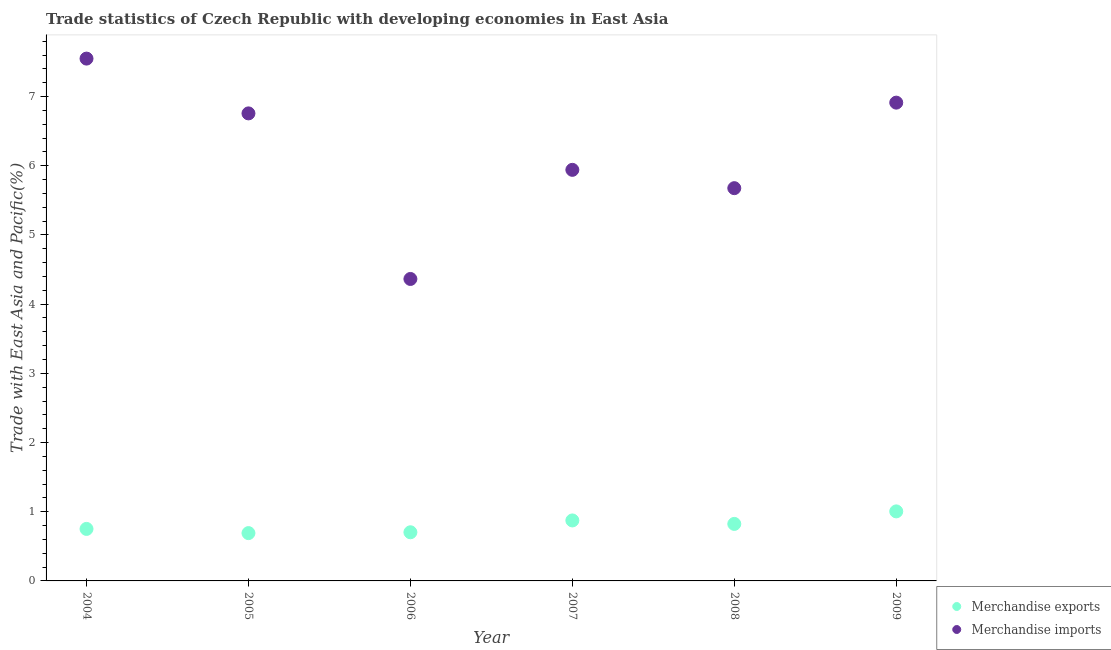How many different coloured dotlines are there?
Keep it short and to the point. 2. What is the merchandise exports in 2005?
Provide a succinct answer. 0.69. Across all years, what is the maximum merchandise imports?
Provide a succinct answer. 7.55. Across all years, what is the minimum merchandise exports?
Keep it short and to the point. 0.69. In which year was the merchandise imports minimum?
Give a very brief answer. 2006. What is the total merchandise imports in the graph?
Ensure brevity in your answer.  37.2. What is the difference between the merchandise imports in 2004 and that in 2006?
Ensure brevity in your answer.  3.18. What is the difference between the merchandise imports in 2009 and the merchandise exports in 2004?
Provide a succinct answer. 6.16. What is the average merchandise imports per year?
Offer a very short reply. 6.2. In the year 2007, what is the difference between the merchandise exports and merchandise imports?
Offer a very short reply. -5.07. What is the ratio of the merchandise exports in 2006 to that in 2007?
Your answer should be very brief. 0.8. Is the merchandise exports in 2004 less than that in 2005?
Offer a terse response. No. What is the difference between the highest and the second highest merchandise imports?
Offer a terse response. 0.64. What is the difference between the highest and the lowest merchandise imports?
Offer a very short reply. 3.18. Is the merchandise exports strictly less than the merchandise imports over the years?
Offer a terse response. Yes. How many dotlines are there?
Make the answer very short. 2. How many years are there in the graph?
Your answer should be very brief. 6. What is the difference between two consecutive major ticks on the Y-axis?
Your answer should be very brief. 1. Does the graph contain any zero values?
Make the answer very short. No. Where does the legend appear in the graph?
Offer a terse response. Bottom right. How are the legend labels stacked?
Provide a succinct answer. Vertical. What is the title of the graph?
Make the answer very short. Trade statistics of Czech Republic with developing economies in East Asia. Does "IMF nonconcessional" appear as one of the legend labels in the graph?
Offer a terse response. No. What is the label or title of the Y-axis?
Ensure brevity in your answer.  Trade with East Asia and Pacific(%). What is the Trade with East Asia and Pacific(%) of Merchandise exports in 2004?
Your answer should be very brief. 0.75. What is the Trade with East Asia and Pacific(%) in Merchandise imports in 2004?
Ensure brevity in your answer.  7.55. What is the Trade with East Asia and Pacific(%) of Merchandise exports in 2005?
Your answer should be very brief. 0.69. What is the Trade with East Asia and Pacific(%) in Merchandise imports in 2005?
Offer a very short reply. 6.76. What is the Trade with East Asia and Pacific(%) in Merchandise exports in 2006?
Provide a short and direct response. 0.7. What is the Trade with East Asia and Pacific(%) in Merchandise imports in 2006?
Keep it short and to the point. 4.36. What is the Trade with East Asia and Pacific(%) in Merchandise exports in 2007?
Provide a succinct answer. 0.87. What is the Trade with East Asia and Pacific(%) in Merchandise imports in 2007?
Make the answer very short. 5.94. What is the Trade with East Asia and Pacific(%) in Merchandise exports in 2008?
Keep it short and to the point. 0.82. What is the Trade with East Asia and Pacific(%) of Merchandise imports in 2008?
Offer a terse response. 5.68. What is the Trade with East Asia and Pacific(%) of Merchandise exports in 2009?
Provide a succinct answer. 1. What is the Trade with East Asia and Pacific(%) in Merchandise imports in 2009?
Ensure brevity in your answer.  6.91. Across all years, what is the maximum Trade with East Asia and Pacific(%) of Merchandise exports?
Provide a succinct answer. 1. Across all years, what is the maximum Trade with East Asia and Pacific(%) of Merchandise imports?
Provide a short and direct response. 7.55. Across all years, what is the minimum Trade with East Asia and Pacific(%) in Merchandise exports?
Provide a succinct answer. 0.69. Across all years, what is the minimum Trade with East Asia and Pacific(%) of Merchandise imports?
Your answer should be compact. 4.36. What is the total Trade with East Asia and Pacific(%) in Merchandise exports in the graph?
Offer a very short reply. 4.85. What is the total Trade with East Asia and Pacific(%) in Merchandise imports in the graph?
Your answer should be very brief. 37.2. What is the difference between the Trade with East Asia and Pacific(%) in Merchandise exports in 2004 and that in 2005?
Offer a very short reply. 0.06. What is the difference between the Trade with East Asia and Pacific(%) in Merchandise imports in 2004 and that in 2005?
Ensure brevity in your answer.  0.79. What is the difference between the Trade with East Asia and Pacific(%) of Merchandise exports in 2004 and that in 2006?
Offer a terse response. 0.05. What is the difference between the Trade with East Asia and Pacific(%) in Merchandise imports in 2004 and that in 2006?
Give a very brief answer. 3.18. What is the difference between the Trade with East Asia and Pacific(%) in Merchandise exports in 2004 and that in 2007?
Make the answer very short. -0.12. What is the difference between the Trade with East Asia and Pacific(%) in Merchandise imports in 2004 and that in 2007?
Your response must be concise. 1.61. What is the difference between the Trade with East Asia and Pacific(%) of Merchandise exports in 2004 and that in 2008?
Offer a very short reply. -0.07. What is the difference between the Trade with East Asia and Pacific(%) in Merchandise imports in 2004 and that in 2008?
Your response must be concise. 1.87. What is the difference between the Trade with East Asia and Pacific(%) of Merchandise exports in 2004 and that in 2009?
Offer a very short reply. -0.25. What is the difference between the Trade with East Asia and Pacific(%) in Merchandise imports in 2004 and that in 2009?
Ensure brevity in your answer.  0.64. What is the difference between the Trade with East Asia and Pacific(%) of Merchandise exports in 2005 and that in 2006?
Your response must be concise. -0.01. What is the difference between the Trade with East Asia and Pacific(%) of Merchandise imports in 2005 and that in 2006?
Your answer should be very brief. 2.39. What is the difference between the Trade with East Asia and Pacific(%) in Merchandise exports in 2005 and that in 2007?
Your answer should be very brief. -0.18. What is the difference between the Trade with East Asia and Pacific(%) of Merchandise imports in 2005 and that in 2007?
Provide a succinct answer. 0.82. What is the difference between the Trade with East Asia and Pacific(%) of Merchandise exports in 2005 and that in 2008?
Make the answer very short. -0.13. What is the difference between the Trade with East Asia and Pacific(%) of Merchandise imports in 2005 and that in 2008?
Your answer should be very brief. 1.08. What is the difference between the Trade with East Asia and Pacific(%) of Merchandise exports in 2005 and that in 2009?
Your answer should be compact. -0.31. What is the difference between the Trade with East Asia and Pacific(%) in Merchandise imports in 2005 and that in 2009?
Ensure brevity in your answer.  -0.16. What is the difference between the Trade with East Asia and Pacific(%) in Merchandise exports in 2006 and that in 2007?
Give a very brief answer. -0.17. What is the difference between the Trade with East Asia and Pacific(%) of Merchandise imports in 2006 and that in 2007?
Make the answer very short. -1.58. What is the difference between the Trade with East Asia and Pacific(%) in Merchandise exports in 2006 and that in 2008?
Keep it short and to the point. -0.12. What is the difference between the Trade with East Asia and Pacific(%) in Merchandise imports in 2006 and that in 2008?
Offer a terse response. -1.31. What is the difference between the Trade with East Asia and Pacific(%) of Merchandise exports in 2006 and that in 2009?
Offer a terse response. -0.3. What is the difference between the Trade with East Asia and Pacific(%) in Merchandise imports in 2006 and that in 2009?
Make the answer very short. -2.55. What is the difference between the Trade with East Asia and Pacific(%) in Merchandise exports in 2007 and that in 2008?
Offer a terse response. 0.05. What is the difference between the Trade with East Asia and Pacific(%) in Merchandise imports in 2007 and that in 2008?
Keep it short and to the point. 0.26. What is the difference between the Trade with East Asia and Pacific(%) of Merchandise exports in 2007 and that in 2009?
Ensure brevity in your answer.  -0.13. What is the difference between the Trade with East Asia and Pacific(%) in Merchandise imports in 2007 and that in 2009?
Your answer should be very brief. -0.97. What is the difference between the Trade with East Asia and Pacific(%) of Merchandise exports in 2008 and that in 2009?
Provide a succinct answer. -0.18. What is the difference between the Trade with East Asia and Pacific(%) in Merchandise imports in 2008 and that in 2009?
Make the answer very short. -1.24. What is the difference between the Trade with East Asia and Pacific(%) of Merchandise exports in 2004 and the Trade with East Asia and Pacific(%) of Merchandise imports in 2005?
Give a very brief answer. -6.01. What is the difference between the Trade with East Asia and Pacific(%) in Merchandise exports in 2004 and the Trade with East Asia and Pacific(%) in Merchandise imports in 2006?
Give a very brief answer. -3.61. What is the difference between the Trade with East Asia and Pacific(%) in Merchandise exports in 2004 and the Trade with East Asia and Pacific(%) in Merchandise imports in 2007?
Provide a short and direct response. -5.19. What is the difference between the Trade with East Asia and Pacific(%) of Merchandise exports in 2004 and the Trade with East Asia and Pacific(%) of Merchandise imports in 2008?
Your answer should be very brief. -4.92. What is the difference between the Trade with East Asia and Pacific(%) of Merchandise exports in 2004 and the Trade with East Asia and Pacific(%) of Merchandise imports in 2009?
Give a very brief answer. -6.16. What is the difference between the Trade with East Asia and Pacific(%) in Merchandise exports in 2005 and the Trade with East Asia and Pacific(%) in Merchandise imports in 2006?
Your answer should be very brief. -3.67. What is the difference between the Trade with East Asia and Pacific(%) of Merchandise exports in 2005 and the Trade with East Asia and Pacific(%) of Merchandise imports in 2007?
Give a very brief answer. -5.25. What is the difference between the Trade with East Asia and Pacific(%) of Merchandise exports in 2005 and the Trade with East Asia and Pacific(%) of Merchandise imports in 2008?
Keep it short and to the point. -4.99. What is the difference between the Trade with East Asia and Pacific(%) in Merchandise exports in 2005 and the Trade with East Asia and Pacific(%) in Merchandise imports in 2009?
Offer a terse response. -6.22. What is the difference between the Trade with East Asia and Pacific(%) of Merchandise exports in 2006 and the Trade with East Asia and Pacific(%) of Merchandise imports in 2007?
Your answer should be very brief. -5.24. What is the difference between the Trade with East Asia and Pacific(%) of Merchandise exports in 2006 and the Trade with East Asia and Pacific(%) of Merchandise imports in 2008?
Give a very brief answer. -4.97. What is the difference between the Trade with East Asia and Pacific(%) of Merchandise exports in 2006 and the Trade with East Asia and Pacific(%) of Merchandise imports in 2009?
Your answer should be compact. -6.21. What is the difference between the Trade with East Asia and Pacific(%) in Merchandise exports in 2007 and the Trade with East Asia and Pacific(%) in Merchandise imports in 2008?
Give a very brief answer. -4.8. What is the difference between the Trade with East Asia and Pacific(%) in Merchandise exports in 2007 and the Trade with East Asia and Pacific(%) in Merchandise imports in 2009?
Provide a succinct answer. -6.04. What is the difference between the Trade with East Asia and Pacific(%) of Merchandise exports in 2008 and the Trade with East Asia and Pacific(%) of Merchandise imports in 2009?
Your answer should be compact. -6.09. What is the average Trade with East Asia and Pacific(%) of Merchandise exports per year?
Keep it short and to the point. 0.81. In the year 2004, what is the difference between the Trade with East Asia and Pacific(%) of Merchandise exports and Trade with East Asia and Pacific(%) of Merchandise imports?
Make the answer very short. -6.8. In the year 2005, what is the difference between the Trade with East Asia and Pacific(%) of Merchandise exports and Trade with East Asia and Pacific(%) of Merchandise imports?
Your answer should be very brief. -6.07. In the year 2006, what is the difference between the Trade with East Asia and Pacific(%) of Merchandise exports and Trade with East Asia and Pacific(%) of Merchandise imports?
Keep it short and to the point. -3.66. In the year 2007, what is the difference between the Trade with East Asia and Pacific(%) of Merchandise exports and Trade with East Asia and Pacific(%) of Merchandise imports?
Keep it short and to the point. -5.07. In the year 2008, what is the difference between the Trade with East Asia and Pacific(%) of Merchandise exports and Trade with East Asia and Pacific(%) of Merchandise imports?
Ensure brevity in your answer.  -4.85. In the year 2009, what is the difference between the Trade with East Asia and Pacific(%) in Merchandise exports and Trade with East Asia and Pacific(%) in Merchandise imports?
Provide a succinct answer. -5.91. What is the ratio of the Trade with East Asia and Pacific(%) in Merchandise exports in 2004 to that in 2005?
Keep it short and to the point. 1.09. What is the ratio of the Trade with East Asia and Pacific(%) in Merchandise imports in 2004 to that in 2005?
Offer a very short reply. 1.12. What is the ratio of the Trade with East Asia and Pacific(%) in Merchandise exports in 2004 to that in 2006?
Provide a succinct answer. 1.07. What is the ratio of the Trade with East Asia and Pacific(%) in Merchandise imports in 2004 to that in 2006?
Provide a succinct answer. 1.73. What is the ratio of the Trade with East Asia and Pacific(%) in Merchandise exports in 2004 to that in 2007?
Your answer should be compact. 0.86. What is the ratio of the Trade with East Asia and Pacific(%) of Merchandise imports in 2004 to that in 2007?
Make the answer very short. 1.27. What is the ratio of the Trade with East Asia and Pacific(%) of Merchandise exports in 2004 to that in 2008?
Give a very brief answer. 0.91. What is the ratio of the Trade with East Asia and Pacific(%) in Merchandise imports in 2004 to that in 2008?
Give a very brief answer. 1.33. What is the ratio of the Trade with East Asia and Pacific(%) in Merchandise exports in 2004 to that in 2009?
Ensure brevity in your answer.  0.75. What is the ratio of the Trade with East Asia and Pacific(%) of Merchandise imports in 2004 to that in 2009?
Your response must be concise. 1.09. What is the ratio of the Trade with East Asia and Pacific(%) in Merchandise exports in 2005 to that in 2006?
Your answer should be very brief. 0.98. What is the ratio of the Trade with East Asia and Pacific(%) in Merchandise imports in 2005 to that in 2006?
Give a very brief answer. 1.55. What is the ratio of the Trade with East Asia and Pacific(%) of Merchandise exports in 2005 to that in 2007?
Your response must be concise. 0.79. What is the ratio of the Trade with East Asia and Pacific(%) in Merchandise imports in 2005 to that in 2007?
Provide a short and direct response. 1.14. What is the ratio of the Trade with East Asia and Pacific(%) of Merchandise exports in 2005 to that in 2008?
Provide a short and direct response. 0.84. What is the ratio of the Trade with East Asia and Pacific(%) of Merchandise imports in 2005 to that in 2008?
Your response must be concise. 1.19. What is the ratio of the Trade with East Asia and Pacific(%) of Merchandise exports in 2005 to that in 2009?
Ensure brevity in your answer.  0.69. What is the ratio of the Trade with East Asia and Pacific(%) of Merchandise imports in 2005 to that in 2009?
Keep it short and to the point. 0.98. What is the ratio of the Trade with East Asia and Pacific(%) of Merchandise exports in 2006 to that in 2007?
Your answer should be very brief. 0.8. What is the ratio of the Trade with East Asia and Pacific(%) in Merchandise imports in 2006 to that in 2007?
Ensure brevity in your answer.  0.73. What is the ratio of the Trade with East Asia and Pacific(%) in Merchandise exports in 2006 to that in 2008?
Offer a very short reply. 0.85. What is the ratio of the Trade with East Asia and Pacific(%) in Merchandise imports in 2006 to that in 2008?
Provide a short and direct response. 0.77. What is the ratio of the Trade with East Asia and Pacific(%) in Merchandise exports in 2006 to that in 2009?
Give a very brief answer. 0.7. What is the ratio of the Trade with East Asia and Pacific(%) of Merchandise imports in 2006 to that in 2009?
Offer a very short reply. 0.63. What is the ratio of the Trade with East Asia and Pacific(%) of Merchandise exports in 2007 to that in 2008?
Offer a terse response. 1.06. What is the ratio of the Trade with East Asia and Pacific(%) of Merchandise imports in 2007 to that in 2008?
Your answer should be very brief. 1.05. What is the ratio of the Trade with East Asia and Pacific(%) of Merchandise exports in 2007 to that in 2009?
Give a very brief answer. 0.87. What is the ratio of the Trade with East Asia and Pacific(%) of Merchandise imports in 2007 to that in 2009?
Keep it short and to the point. 0.86. What is the ratio of the Trade with East Asia and Pacific(%) of Merchandise exports in 2008 to that in 2009?
Give a very brief answer. 0.82. What is the ratio of the Trade with East Asia and Pacific(%) in Merchandise imports in 2008 to that in 2009?
Keep it short and to the point. 0.82. What is the difference between the highest and the second highest Trade with East Asia and Pacific(%) of Merchandise exports?
Ensure brevity in your answer.  0.13. What is the difference between the highest and the second highest Trade with East Asia and Pacific(%) of Merchandise imports?
Your answer should be very brief. 0.64. What is the difference between the highest and the lowest Trade with East Asia and Pacific(%) in Merchandise exports?
Provide a succinct answer. 0.31. What is the difference between the highest and the lowest Trade with East Asia and Pacific(%) in Merchandise imports?
Your answer should be very brief. 3.18. 